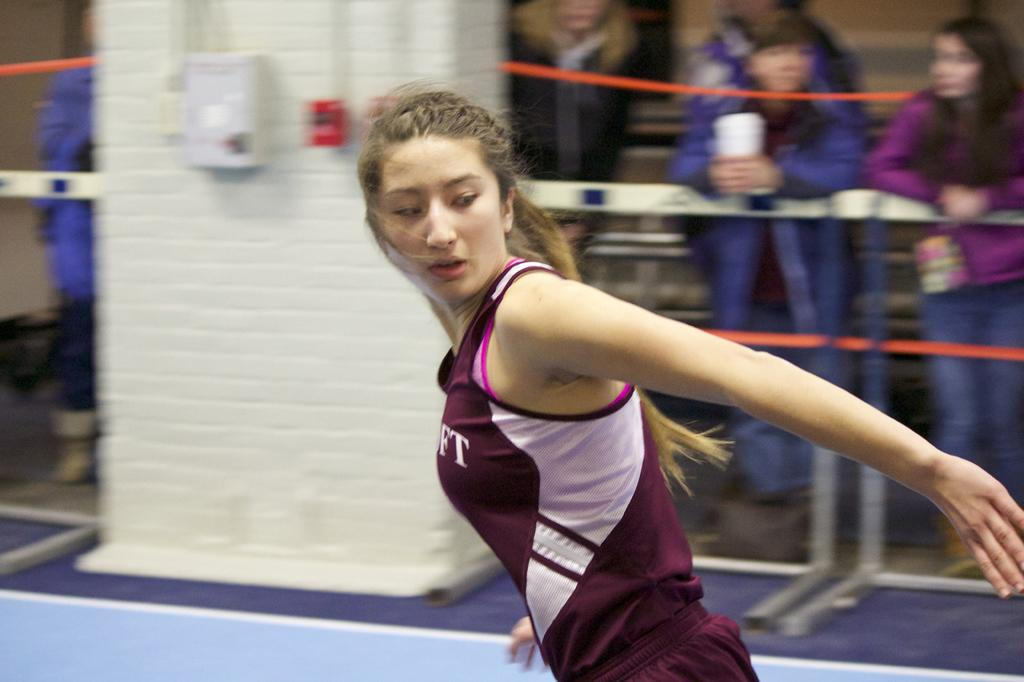What is the woman in the image doing? The woman is running in the image. Where is the woman located in the image? The woman is on the floor. What can be seen in the background of the image? There is a pillar with a fence in the image, and persons are standing behind the fence. What type of beetle can be seen crawling on the woman's shoulder in the image? There is no beetle present on the woman's shoulder in the image. 